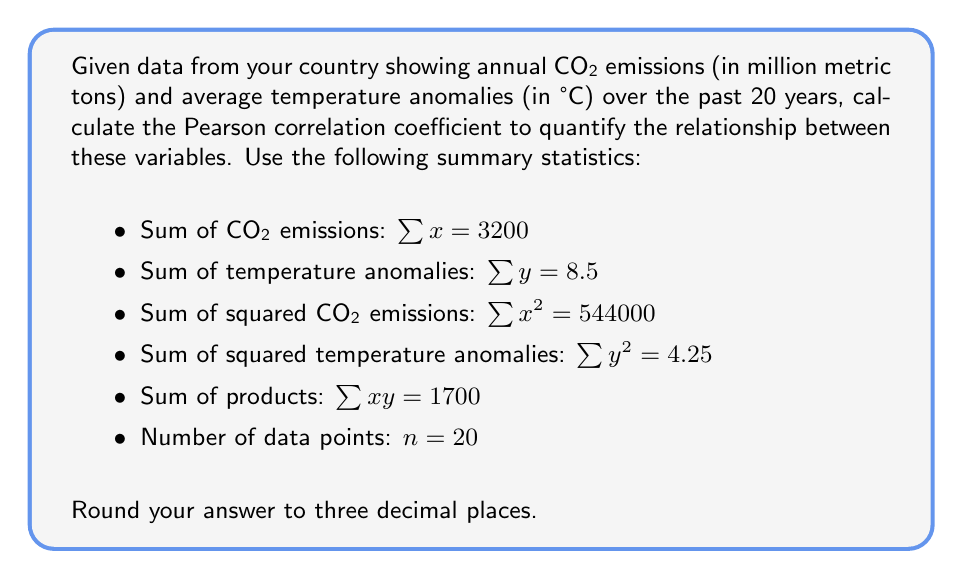Show me your answer to this math problem. To calculate the Pearson correlation coefficient (r), we'll use the formula:

$$r = \frac{n\sum xy - \sum x \sum y}{\sqrt{[n\sum x^2 - (\sum x)^2][n\sum y^2 - (\sum y)^2]}}$$

Let's substitute the given values:

1) $n = 20$
2) $\sum x = 3200$
3) $\sum y = 8.5$
4) $\sum x^2 = 544000$
5) $\sum y^2 = 4.25$
6) $\sum xy = 1700$

Now, let's calculate step by step:

Step 1: Calculate $n\sum xy$
$20 \times 1700 = 34000$

Step 2: Calculate $\sum x \sum y$
$3200 \times 8.5 = 27200$

Step 3: Calculate the numerator
$34000 - 27200 = 6800$

Step 4: Calculate $n\sum x^2$
$20 \times 544000 = 10880000$

Step 5: Calculate $(\sum x)^2$
$3200^2 = 10240000$

Step 6: Calculate $n\sum y^2$
$20 \times 4.25 = 85$

Step 7: Calculate $(\sum y)^2$
$8.5^2 = 72.25$

Step 8: Calculate the denominator
$\sqrt{(10880000 - 10240000)(85 - 72.25)} = \sqrt{640000 \times 12.75} = \sqrt{8160000} = 2856.57$

Step 9: Divide the numerator by the denominator
$r = \frac{6800}{2856.57} = 2.380$

Step 10: Round to three decimal places
$r = 2.380$
Answer: $r = 2.380$ 